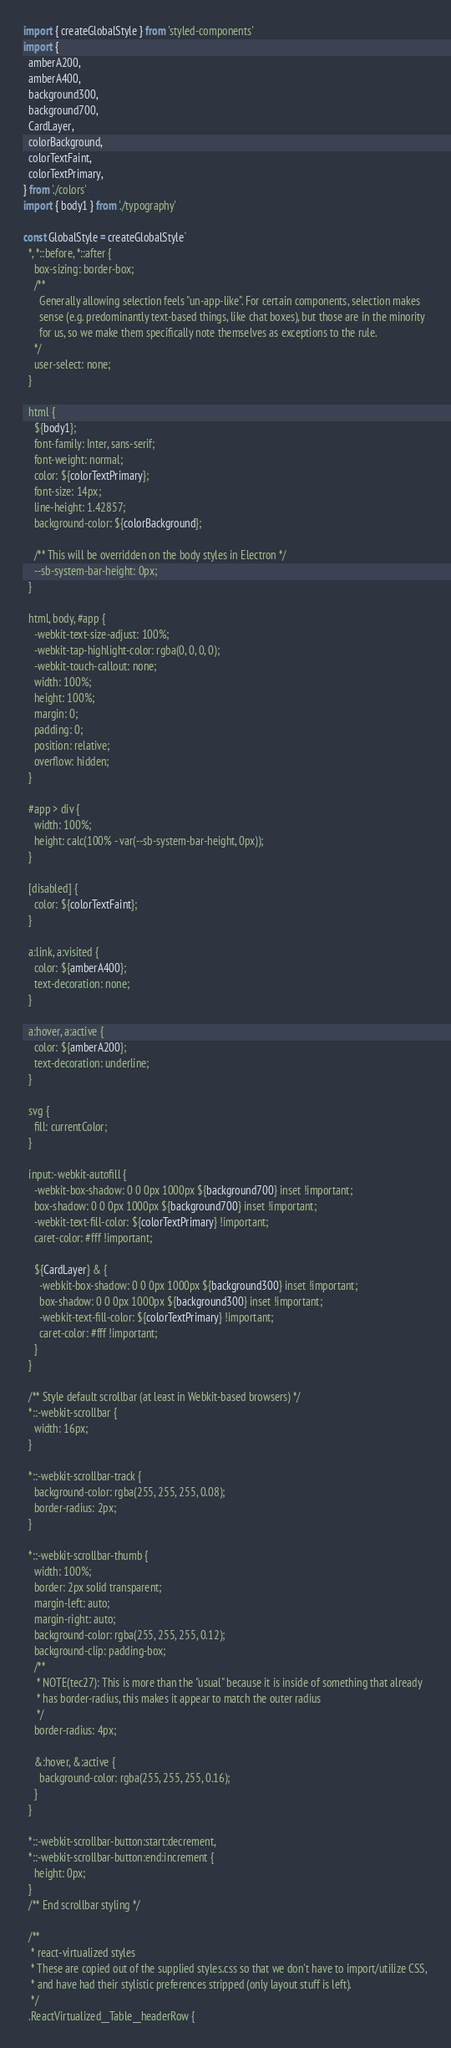Convert code to text. <code><loc_0><loc_0><loc_500><loc_500><_TypeScript_>import { createGlobalStyle } from 'styled-components'
import {
  amberA200,
  amberA400,
  background300,
  background700,
  CardLayer,
  colorBackground,
  colorTextFaint,
  colorTextPrimary,
} from './colors'
import { body1 } from './typography'

const GlobalStyle = createGlobalStyle`
  *, *::before, *::after {
    box-sizing: border-box;
    /**
      Generally allowing selection feels "un-app-like". For certain components, selection makes
      sense (e.g. predominantly text-based things, like chat boxes), but those are in the minority
      for us, so we make them specifically note themselves as exceptions to the rule.
    */
    user-select: none;
  }

  html {
    ${body1};
    font-family: Inter, sans-serif;
    font-weight: normal;
    color: ${colorTextPrimary};
    font-size: 14px;
    line-height: 1.42857;
    background-color: ${colorBackground};

    /** This will be overridden on the body styles in Electron */
    --sb-system-bar-height: 0px;
  }

  html, body, #app {
    -webkit-text-size-adjust: 100%;
    -webkit-tap-highlight-color: rgba(0, 0, 0, 0);
    -webkit-touch-callout: none;
    width: 100%;
    height: 100%;
    margin: 0;
    padding: 0;
    position: relative;
    overflow: hidden;
  }

  #app > div {
    width: 100%;
    height: calc(100% - var(--sb-system-bar-height, 0px));
  }

  [disabled] {
    color: ${colorTextFaint};
  }

  a:link, a:visited {
    color: ${amberA400};
    text-decoration: none;
  }

  a:hover, a:active {
    color: ${amberA200};
    text-decoration: underline;
  }

  svg {
    fill: currentColor;
  }

  input:-webkit-autofill {
    -webkit-box-shadow: 0 0 0px 1000px ${background700} inset !important;
    box-shadow: 0 0 0px 1000px ${background700} inset !important;
    -webkit-text-fill-color: ${colorTextPrimary} !important;
    caret-color: #fff !important;

    ${CardLayer} & {
      -webkit-box-shadow: 0 0 0px 1000px ${background300} inset !important;
      box-shadow: 0 0 0px 1000px ${background300} inset !important;
      -webkit-text-fill-color: ${colorTextPrimary} !important;
      caret-color: #fff !important;
    }
  }

  /** Style default scrollbar (at least in Webkit-based browsers) */
  *::-webkit-scrollbar {
    width: 16px;
  }

  *::-webkit-scrollbar-track {
    background-color: rgba(255, 255, 255, 0.08);
    border-radius: 2px;
  }

  *::-webkit-scrollbar-thumb {
    width: 100%;
    border: 2px solid transparent;
    margin-left: auto;
    margin-right: auto;
    background-color: rgba(255, 255, 255, 0.12);
    background-clip: padding-box;
    /**
     * NOTE(tec27): This is more than the "usual" because it is inside of something that already
     * has border-radius, this makes it appear to match the outer radius
     */
    border-radius: 4px;

    &:hover, &:active {
      background-color: rgba(255, 255, 255, 0.16);
    }
  }

  *::-webkit-scrollbar-button:start:decrement,
  *::-webkit-scrollbar-button:end:increment {
    height: 0px;
  }
  /** End scrollbar styling */

  /**
   * react-virtualized styles
   * These are copied out of the supplied styles.css so that we don't have to import/utilize CSS,
   * and have had their stylistic preferences stripped (only layout stuff is left).
   */
  .ReactVirtualized__Table__headerRow {</code> 